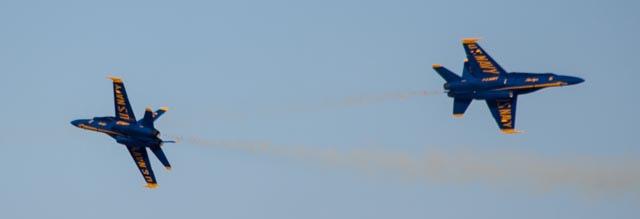Are the planes blue and gold?
Quick response, please. Yes. How many planes are in the sky?
Give a very brief answer. 2. How many planes?
Keep it brief. 2. What is coming from the back of the jets?
Keep it brief. Smoke. Is one of the planes upside-down?
Answer briefly. No. 